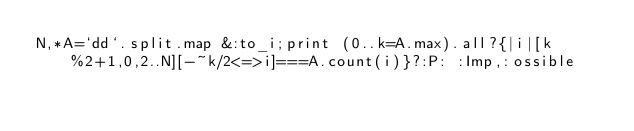<code> <loc_0><loc_0><loc_500><loc_500><_Ruby_>N,*A=`dd`.split.map &:to_i;print (0..k=A.max).all?{|i|[k%2+1,0,2..N][-~k/2<=>i]===A.count(i)}?:P: :Imp,:ossible</code> 